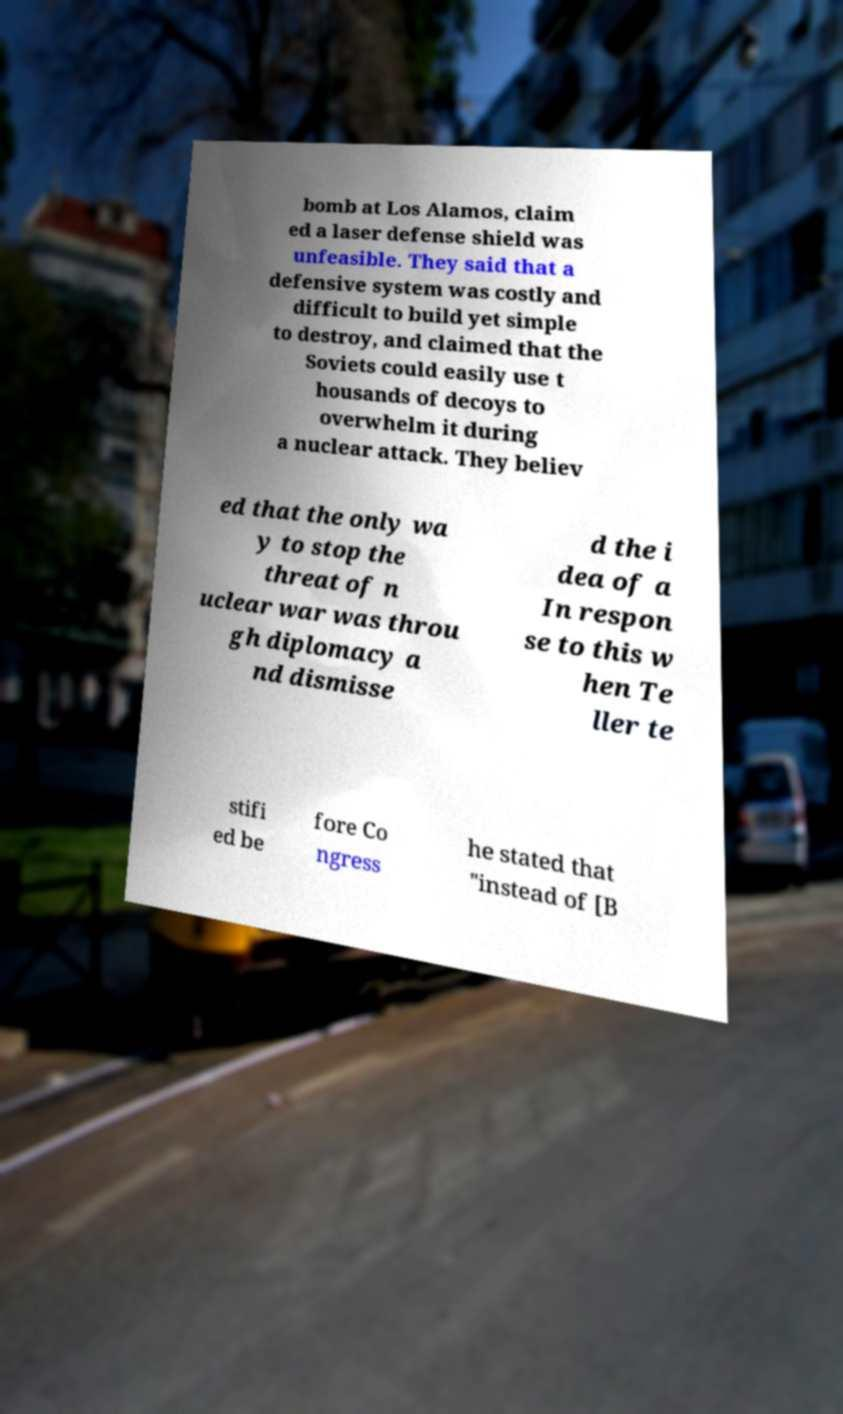Can you accurately transcribe the text from the provided image for me? bomb at Los Alamos, claim ed a laser defense shield was unfeasible. They said that a defensive system was costly and difficult to build yet simple to destroy, and claimed that the Soviets could easily use t housands of decoys to overwhelm it during a nuclear attack. They believ ed that the only wa y to stop the threat of n uclear war was throu gh diplomacy a nd dismisse d the i dea of a In respon se to this w hen Te ller te stifi ed be fore Co ngress he stated that "instead of [B 